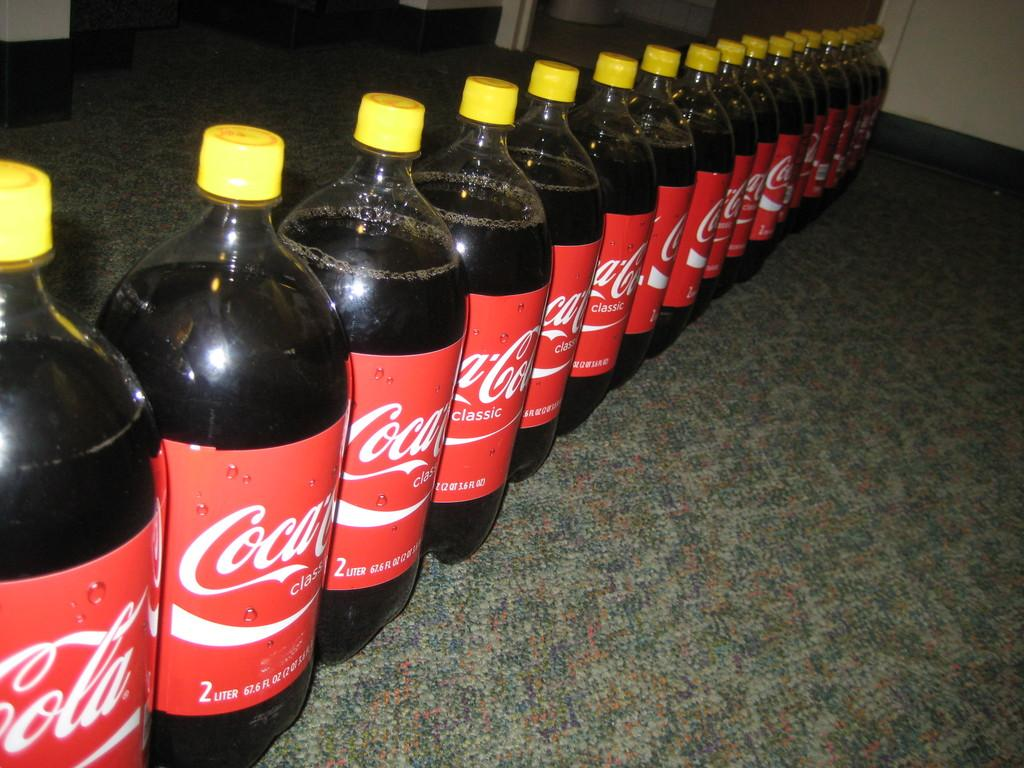What type of bottles are visible in the image? There are many bottles in the image, and they have a Coca Cola label. What color are the caps of the bottles? The caps of the bottles are yellow in color. Where are the bottles placed in the image? The bottles are kept on a surface. How many letters can be seen spelling out a message on the bottles in the image? There is no indication in the image that the bottles have any letters spelling out a message. Can you see any lizards crawling on the bottles in the image? There are no lizards present in the image. 